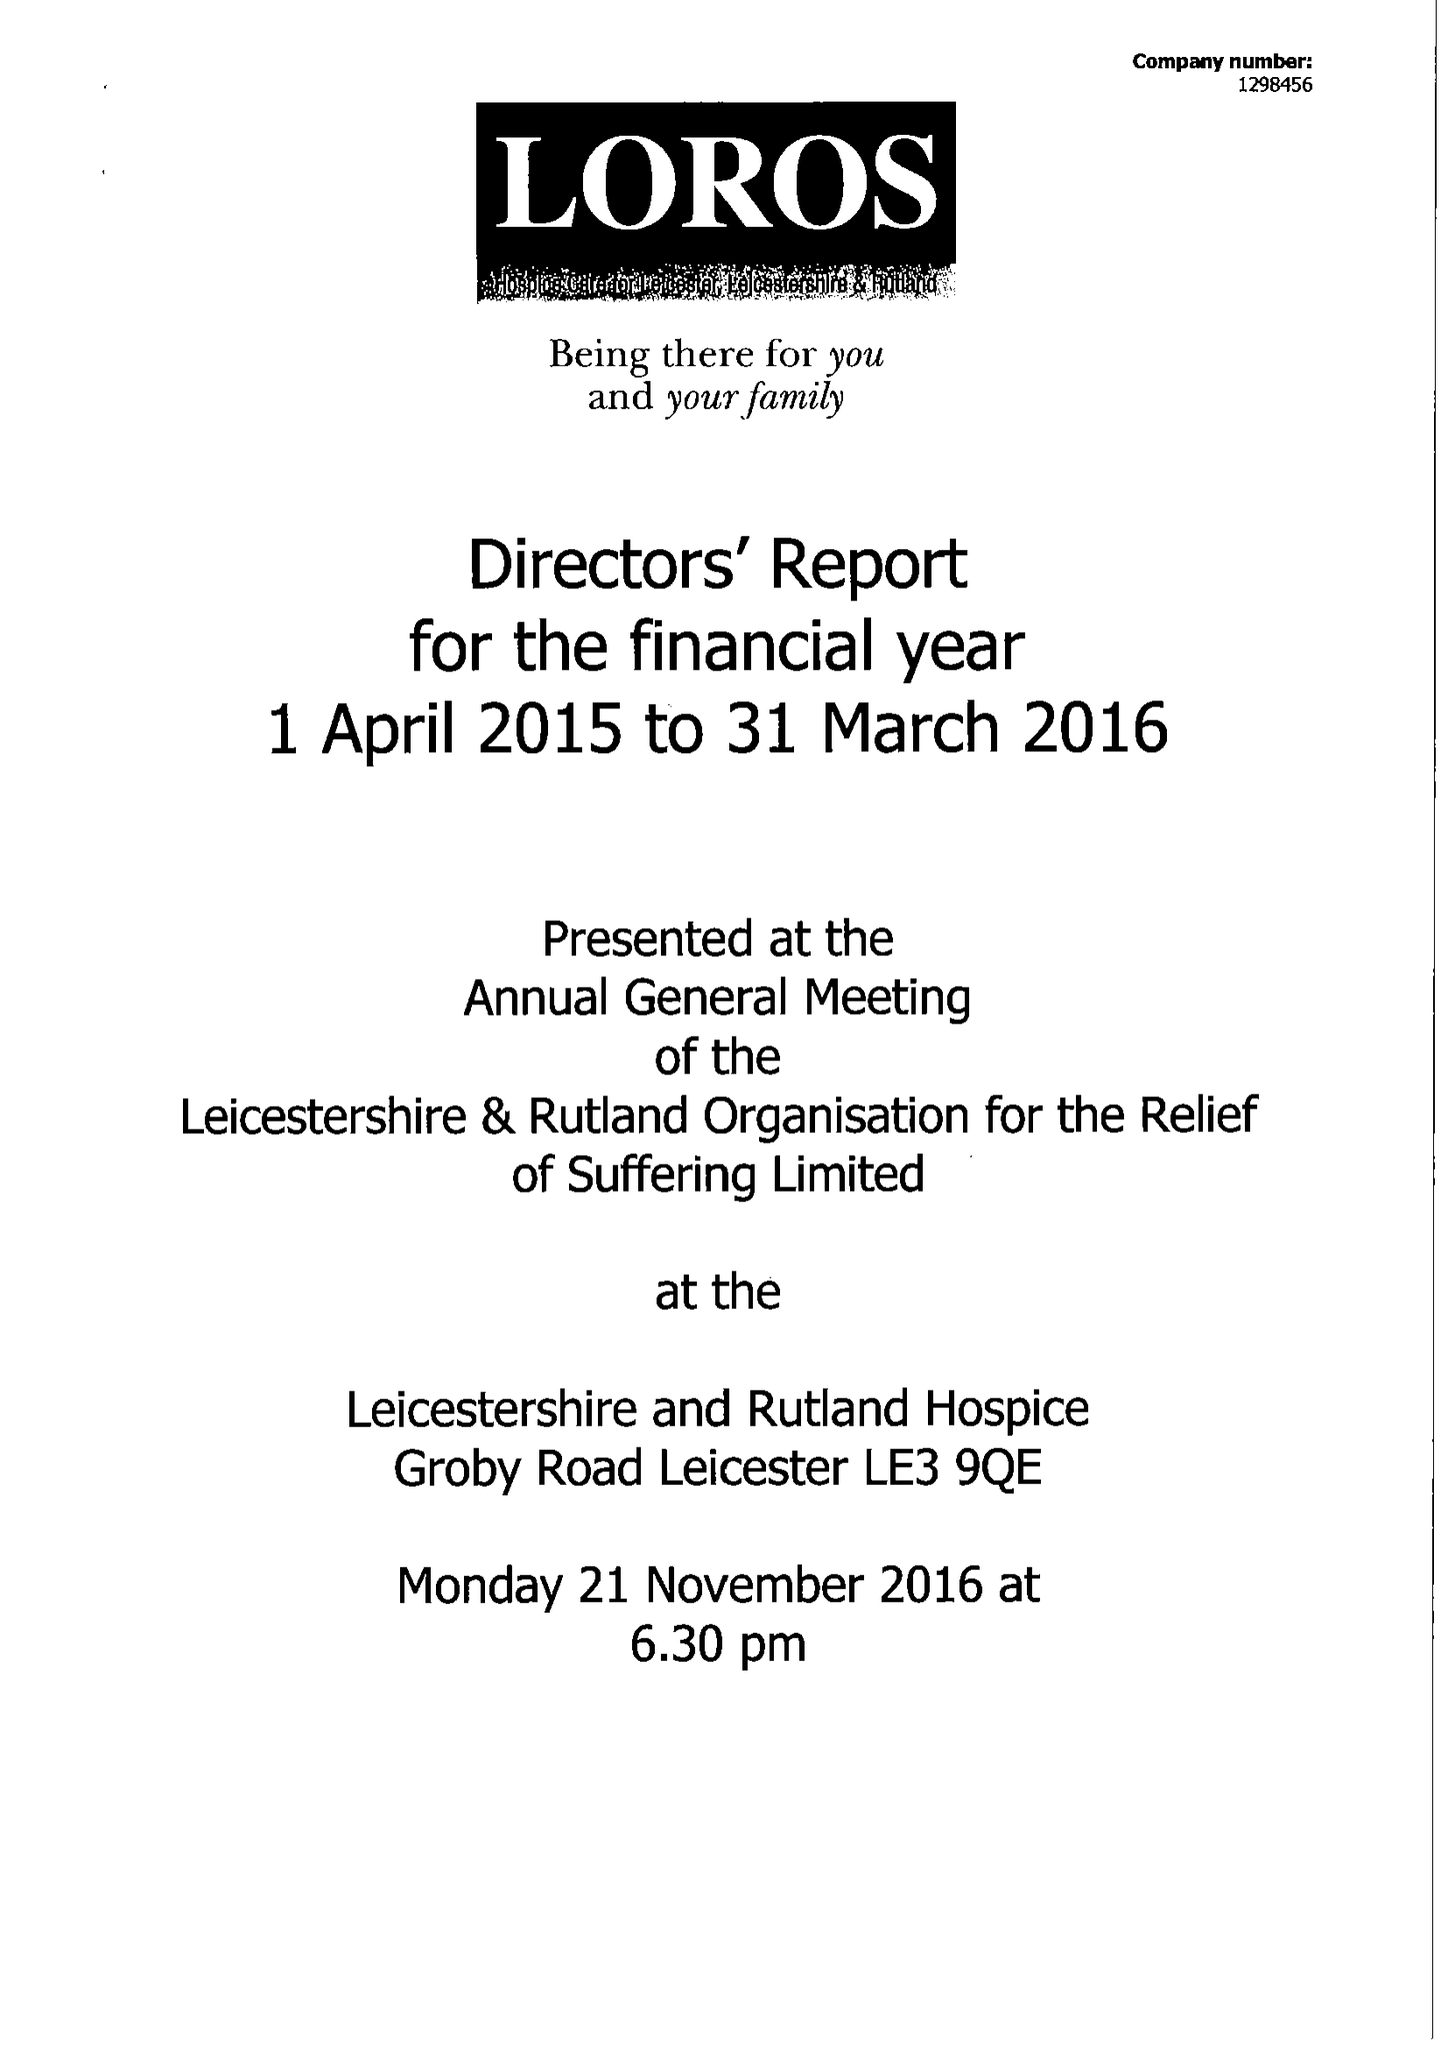What is the value for the address__postcode?
Answer the question using a single word or phrase. LE3 9QE 